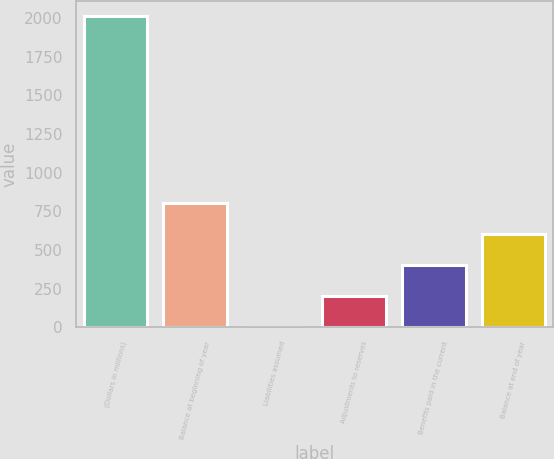<chart> <loc_0><loc_0><loc_500><loc_500><bar_chart><fcel>(Dollars in millions)<fcel>Balance at beginning of year<fcel>Liabilities assumed<fcel>Adjustments to reserves<fcel>Benefits paid in the current<fcel>Balance at end of year<nl><fcel>2012<fcel>804.86<fcel>0.1<fcel>201.29<fcel>402.48<fcel>603.67<nl></chart> 